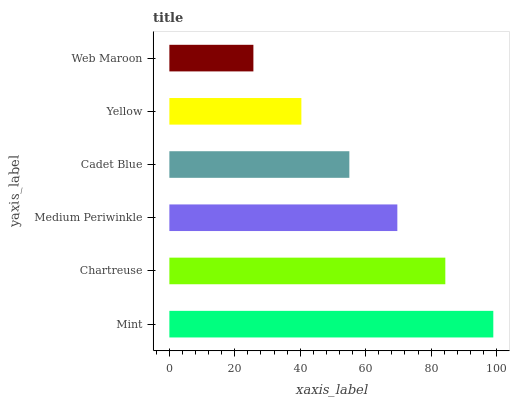Is Web Maroon the minimum?
Answer yes or no. Yes. Is Mint the maximum?
Answer yes or no. Yes. Is Chartreuse the minimum?
Answer yes or no. No. Is Chartreuse the maximum?
Answer yes or no. No. Is Mint greater than Chartreuse?
Answer yes or no. Yes. Is Chartreuse less than Mint?
Answer yes or no. Yes. Is Chartreuse greater than Mint?
Answer yes or no. No. Is Mint less than Chartreuse?
Answer yes or no. No. Is Medium Periwinkle the high median?
Answer yes or no. Yes. Is Cadet Blue the low median?
Answer yes or no. Yes. Is Web Maroon the high median?
Answer yes or no. No. Is Medium Periwinkle the low median?
Answer yes or no. No. 